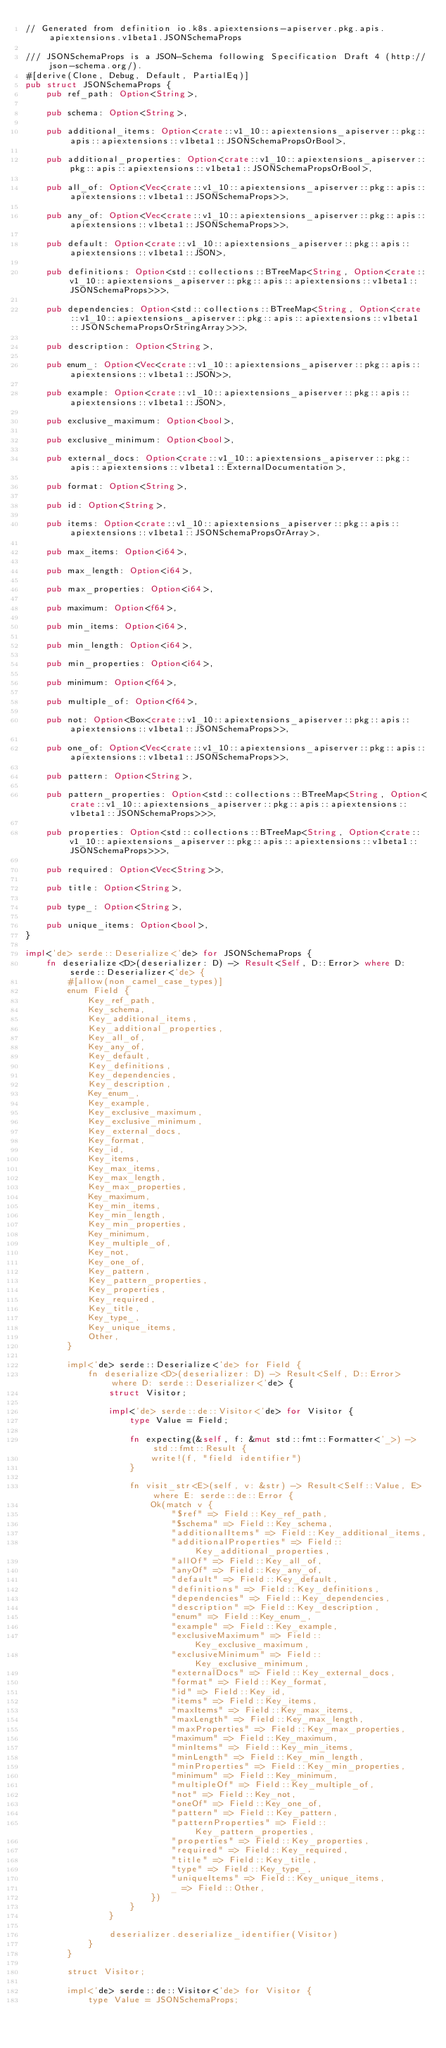Convert code to text. <code><loc_0><loc_0><loc_500><loc_500><_Rust_>// Generated from definition io.k8s.apiextensions-apiserver.pkg.apis.apiextensions.v1beta1.JSONSchemaProps

/// JSONSchemaProps is a JSON-Schema following Specification Draft 4 (http://json-schema.org/).
#[derive(Clone, Debug, Default, PartialEq)]
pub struct JSONSchemaProps {
    pub ref_path: Option<String>,

    pub schema: Option<String>,

    pub additional_items: Option<crate::v1_10::apiextensions_apiserver::pkg::apis::apiextensions::v1beta1::JSONSchemaPropsOrBool>,

    pub additional_properties: Option<crate::v1_10::apiextensions_apiserver::pkg::apis::apiextensions::v1beta1::JSONSchemaPropsOrBool>,

    pub all_of: Option<Vec<crate::v1_10::apiextensions_apiserver::pkg::apis::apiextensions::v1beta1::JSONSchemaProps>>,

    pub any_of: Option<Vec<crate::v1_10::apiextensions_apiserver::pkg::apis::apiextensions::v1beta1::JSONSchemaProps>>,

    pub default: Option<crate::v1_10::apiextensions_apiserver::pkg::apis::apiextensions::v1beta1::JSON>,

    pub definitions: Option<std::collections::BTreeMap<String, Option<crate::v1_10::apiextensions_apiserver::pkg::apis::apiextensions::v1beta1::JSONSchemaProps>>>,

    pub dependencies: Option<std::collections::BTreeMap<String, Option<crate::v1_10::apiextensions_apiserver::pkg::apis::apiextensions::v1beta1::JSONSchemaPropsOrStringArray>>>,

    pub description: Option<String>,

    pub enum_: Option<Vec<crate::v1_10::apiextensions_apiserver::pkg::apis::apiextensions::v1beta1::JSON>>,

    pub example: Option<crate::v1_10::apiextensions_apiserver::pkg::apis::apiextensions::v1beta1::JSON>,

    pub exclusive_maximum: Option<bool>,

    pub exclusive_minimum: Option<bool>,

    pub external_docs: Option<crate::v1_10::apiextensions_apiserver::pkg::apis::apiextensions::v1beta1::ExternalDocumentation>,

    pub format: Option<String>,

    pub id: Option<String>,

    pub items: Option<crate::v1_10::apiextensions_apiserver::pkg::apis::apiextensions::v1beta1::JSONSchemaPropsOrArray>,

    pub max_items: Option<i64>,

    pub max_length: Option<i64>,

    pub max_properties: Option<i64>,

    pub maximum: Option<f64>,

    pub min_items: Option<i64>,

    pub min_length: Option<i64>,

    pub min_properties: Option<i64>,

    pub minimum: Option<f64>,

    pub multiple_of: Option<f64>,

    pub not: Option<Box<crate::v1_10::apiextensions_apiserver::pkg::apis::apiextensions::v1beta1::JSONSchemaProps>>,

    pub one_of: Option<Vec<crate::v1_10::apiextensions_apiserver::pkg::apis::apiextensions::v1beta1::JSONSchemaProps>>,

    pub pattern: Option<String>,

    pub pattern_properties: Option<std::collections::BTreeMap<String, Option<crate::v1_10::apiextensions_apiserver::pkg::apis::apiextensions::v1beta1::JSONSchemaProps>>>,

    pub properties: Option<std::collections::BTreeMap<String, Option<crate::v1_10::apiextensions_apiserver::pkg::apis::apiextensions::v1beta1::JSONSchemaProps>>>,

    pub required: Option<Vec<String>>,

    pub title: Option<String>,

    pub type_: Option<String>,

    pub unique_items: Option<bool>,
}

impl<'de> serde::Deserialize<'de> for JSONSchemaProps {
    fn deserialize<D>(deserializer: D) -> Result<Self, D::Error> where D: serde::Deserializer<'de> {
        #[allow(non_camel_case_types)]
        enum Field {
            Key_ref_path,
            Key_schema,
            Key_additional_items,
            Key_additional_properties,
            Key_all_of,
            Key_any_of,
            Key_default,
            Key_definitions,
            Key_dependencies,
            Key_description,
            Key_enum_,
            Key_example,
            Key_exclusive_maximum,
            Key_exclusive_minimum,
            Key_external_docs,
            Key_format,
            Key_id,
            Key_items,
            Key_max_items,
            Key_max_length,
            Key_max_properties,
            Key_maximum,
            Key_min_items,
            Key_min_length,
            Key_min_properties,
            Key_minimum,
            Key_multiple_of,
            Key_not,
            Key_one_of,
            Key_pattern,
            Key_pattern_properties,
            Key_properties,
            Key_required,
            Key_title,
            Key_type_,
            Key_unique_items,
            Other,
        }

        impl<'de> serde::Deserialize<'de> for Field {
            fn deserialize<D>(deserializer: D) -> Result<Self, D::Error> where D: serde::Deserializer<'de> {
                struct Visitor;

                impl<'de> serde::de::Visitor<'de> for Visitor {
                    type Value = Field;

                    fn expecting(&self, f: &mut std::fmt::Formatter<'_>) -> std::fmt::Result {
                        write!(f, "field identifier")
                    }

                    fn visit_str<E>(self, v: &str) -> Result<Self::Value, E> where E: serde::de::Error {
                        Ok(match v {
                            "$ref" => Field::Key_ref_path,
                            "$schema" => Field::Key_schema,
                            "additionalItems" => Field::Key_additional_items,
                            "additionalProperties" => Field::Key_additional_properties,
                            "allOf" => Field::Key_all_of,
                            "anyOf" => Field::Key_any_of,
                            "default" => Field::Key_default,
                            "definitions" => Field::Key_definitions,
                            "dependencies" => Field::Key_dependencies,
                            "description" => Field::Key_description,
                            "enum" => Field::Key_enum_,
                            "example" => Field::Key_example,
                            "exclusiveMaximum" => Field::Key_exclusive_maximum,
                            "exclusiveMinimum" => Field::Key_exclusive_minimum,
                            "externalDocs" => Field::Key_external_docs,
                            "format" => Field::Key_format,
                            "id" => Field::Key_id,
                            "items" => Field::Key_items,
                            "maxItems" => Field::Key_max_items,
                            "maxLength" => Field::Key_max_length,
                            "maxProperties" => Field::Key_max_properties,
                            "maximum" => Field::Key_maximum,
                            "minItems" => Field::Key_min_items,
                            "minLength" => Field::Key_min_length,
                            "minProperties" => Field::Key_min_properties,
                            "minimum" => Field::Key_minimum,
                            "multipleOf" => Field::Key_multiple_of,
                            "not" => Field::Key_not,
                            "oneOf" => Field::Key_one_of,
                            "pattern" => Field::Key_pattern,
                            "patternProperties" => Field::Key_pattern_properties,
                            "properties" => Field::Key_properties,
                            "required" => Field::Key_required,
                            "title" => Field::Key_title,
                            "type" => Field::Key_type_,
                            "uniqueItems" => Field::Key_unique_items,
                            _ => Field::Other,
                        })
                    }
                }

                deserializer.deserialize_identifier(Visitor)
            }
        }

        struct Visitor;

        impl<'de> serde::de::Visitor<'de> for Visitor {
            type Value = JSONSchemaProps;
</code> 